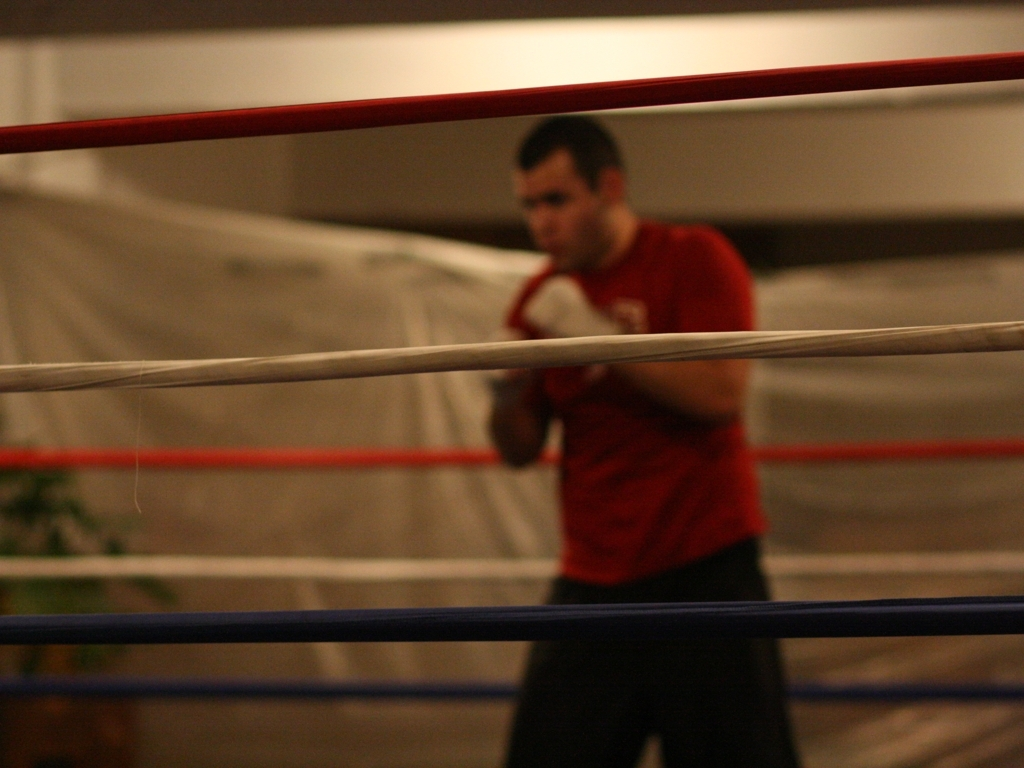What emotions does the image evoke? The image evokes a sense of determination and grit. The boxer's stance, the concentration in his pose, and the ambiance of the gym all contribute to a feeling of dedication and hard work towards athletic improvement. 